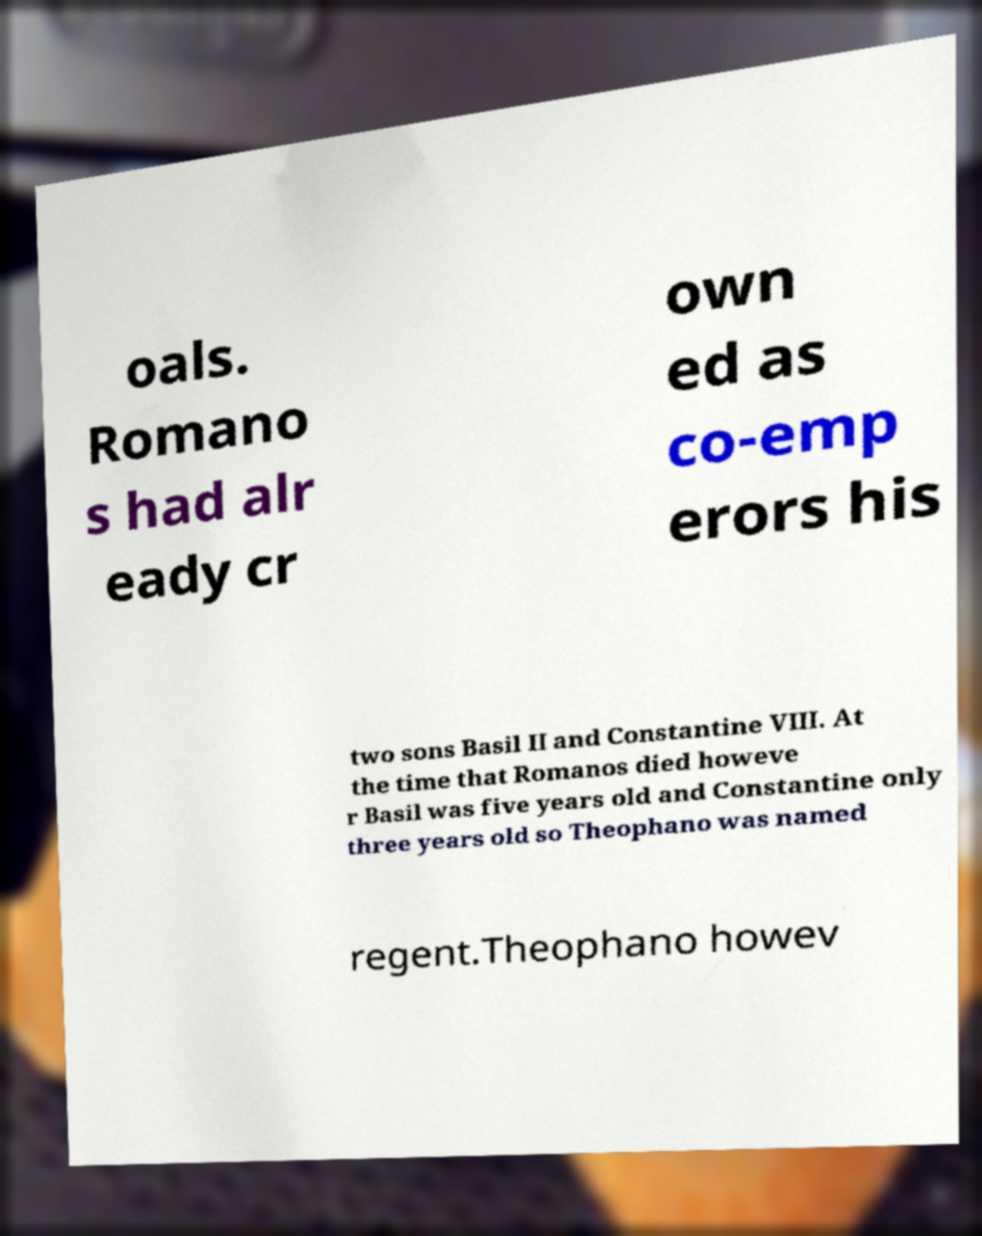Please read and relay the text visible in this image. What does it say? oals. Romano s had alr eady cr own ed as co-emp erors his two sons Basil II and Constantine VIII. At the time that Romanos died howeve r Basil was five years old and Constantine only three years old so Theophano was named regent.Theophano howev 